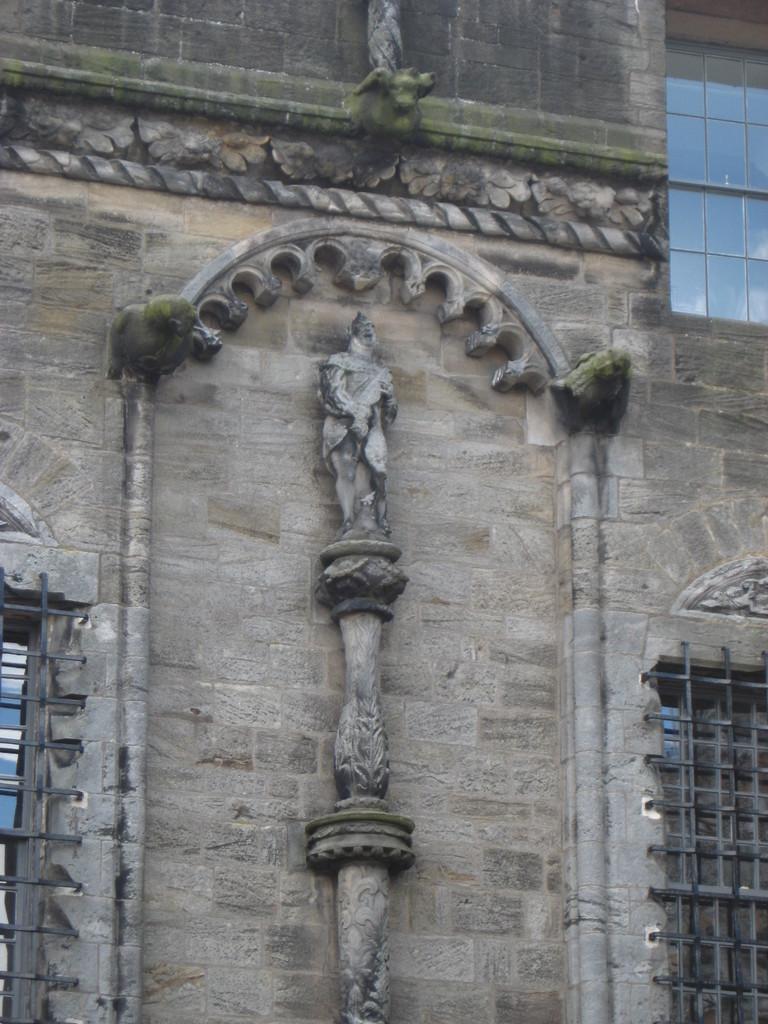Could you give a brief overview of what you see in this image? In the center of the image there is a building and we can see sculptures on the building. On the right there are windows. 